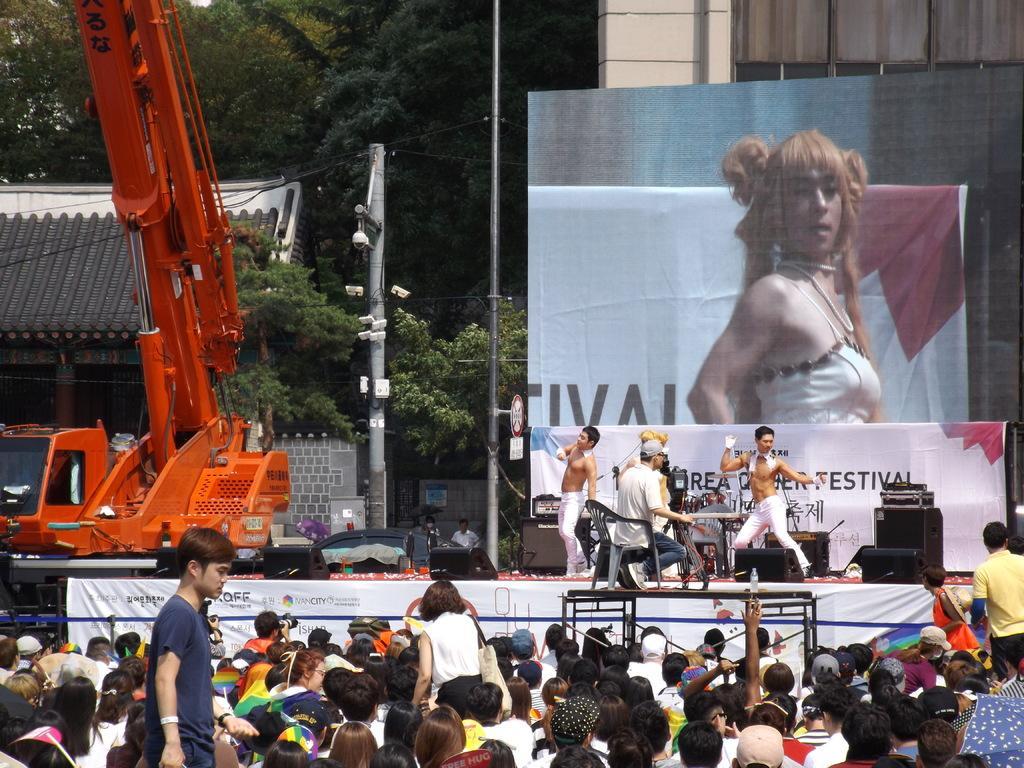In one or two sentences, can you explain what this image depicts? There are persons in different color dresses, sitting. There are persons standing. In the background, there is a person sitting on a chair and capturing video of the persons who are dancing on the stage on which, there are speakers, there is a proc-line, a hoarding, a screen, building, there are poles and trees. 